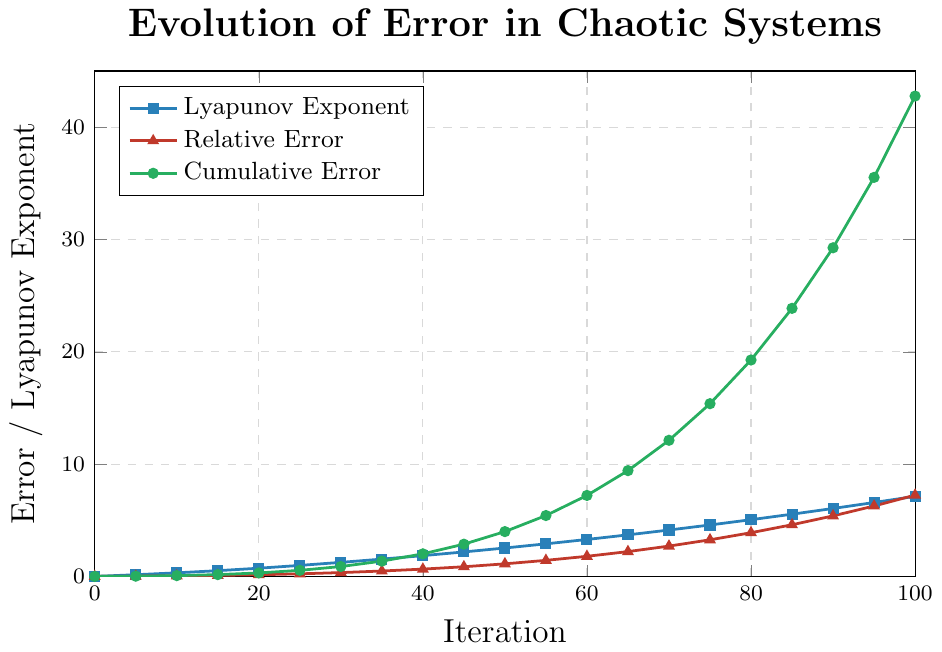Which quantity shows the steepest increase as iterations progress? By observing the slope of the lines in the figure, the Cumulative Error line (green) shows the steepest increase, especially after 50 iterations, compared to the Relative Error (red) and Lyapunov Exponent (blue) lines.
Answer: Cumulative Error At which iteration does the Relative Error first exceed 1.0? Locate the point where the red line (Relative Error) first crosses the value of 1.0 on the y-axis. This happens between iterations 45 and 50, and it is specifically at iteration 50 where Relative Error is 1.12.
Answer: 50 What is the difference in Lyapunov Exponent between iteration 60 and iteration 80? Read the Lyapunov Exponent values at iterations 60 and 80 from the blue line: they are 3.29 and 5.05, respectively. Subtract the value at iteration 60 from the value at iteration 80: 5.05 - 3.29 = 1.76.
Answer: 1.76 Compare the Cumulative Error and Lyapunov Exponent at iteration 35. Which is larger? Read the values at iteration 35: the Cumulative Error (green line) is 1.36 and the Lyapunov Exponent (blue line) is 1.54. Since 1.54 > 1.36, the Lyapunov Exponent is larger.
Answer: Lyapunov Exponent By how much does the Cumulative Error increase between iteration 70 and 90? Read the Cumulative Error values at iterations 70 and 90: they are 12.12 and 29.26, respectively. Subtract the value at iteration 70 from the value at iteration 90: 29.26 - 12.12 = 17.14.
Answer: 17.14 How do the slopes of the Lyapunov Exponent and Relative Error change after iteration 50? Observe the slope of the Lyapunov Exponent (blue line) and Relative Error (red line) before and after iteration 50. Both slopes become steeper after iteration 50, indicating a faster increase rate.
Answer: Steeper At what iteration does the Lyapunov Exponent reach 4.0? Locate the point on the blue line where the Lyapunov Exponent reaches 4.0. This happens between iterations 65 and 70, around iteration 67.5.
Answer: Around 67.5 What is the average Lyapunov Exponent between iterations 20 and 40? Read the Lyapunov Exponent values at iterations 20, 25, 30, 35, and 40: these are 0.73, 0.98, 1.25, 1.54, and 1.85. Sum these values: 0.73 + 0.98 + 1.25 + 1.54 + 1.85 = 6.35. Divide by the number of points (5) to get the average: 6.35 / 5 = 1.27.
Answer: 1.27 How does the rate of increase for the Relative Error compare to the Lyapunov Exponent over the first 20 iterations? Over the first 20 iterations, observe the slope of the red line (Relative Error) and the blue line (Lyapunov Exponent). The Lyapunov Exponent increases at a faster rate compared to the Relative Error since its slope is steeper.
Answer: Faster for Lyapunov Exponent What is the cumulative error at iteration 50, and what does it signify in terms of error propagation? The cumulative error at iteration 50 is 3.99 as per the green line. This high value indicates significant error propagation in chaotic systems over iterations.
Answer: 3.99 